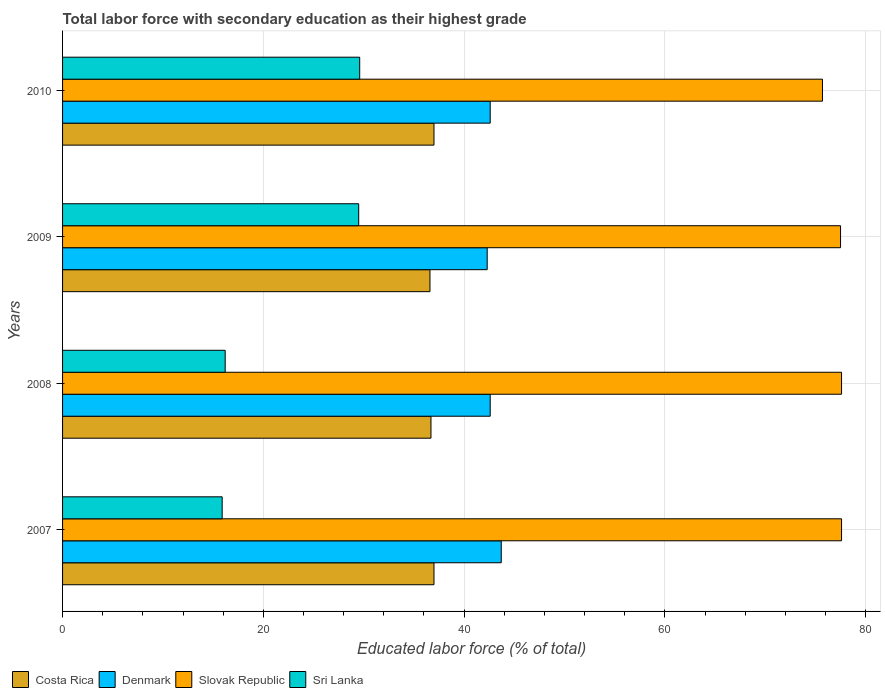How many groups of bars are there?
Your response must be concise. 4. Are the number of bars per tick equal to the number of legend labels?
Your answer should be very brief. Yes. How many bars are there on the 1st tick from the bottom?
Keep it short and to the point. 4. What is the label of the 1st group of bars from the top?
Keep it short and to the point. 2010. In how many cases, is the number of bars for a given year not equal to the number of legend labels?
Provide a succinct answer. 0. What is the percentage of total labor force with primary education in Denmark in 2007?
Ensure brevity in your answer.  43.7. Across all years, what is the maximum percentage of total labor force with primary education in Sri Lanka?
Make the answer very short. 29.6. Across all years, what is the minimum percentage of total labor force with primary education in Denmark?
Offer a very short reply. 42.3. In which year was the percentage of total labor force with primary education in Denmark minimum?
Make the answer very short. 2009. What is the total percentage of total labor force with primary education in Costa Rica in the graph?
Offer a terse response. 147.3. What is the difference between the percentage of total labor force with primary education in Slovak Republic in 2008 and that in 2010?
Your answer should be compact. 1.9. What is the difference between the percentage of total labor force with primary education in Sri Lanka in 2009 and the percentage of total labor force with primary education in Slovak Republic in 2008?
Ensure brevity in your answer.  -48.1. What is the average percentage of total labor force with primary education in Denmark per year?
Provide a short and direct response. 42.8. In the year 2008, what is the difference between the percentage of total labor force with primary education in Costa Rica and percentage of total labor force with primary education in Slovak Republic?
Offer a very short reply. -40.9. In how many years, is the percentage of total labor force with primary education in Denmark greater than 44 %?
Keep it short and to the point. 0. What is the ratio of the percentage of total labor force with primary education in Slovak Republic in 2008 to that in 2009?
Keep it short and to the point. 1. What is the difference between the highest and the second highest percentage of total labor force with primary education in Sri Lanka?
Keep it short and to the point. 0.1. What is the difference between the highest and the lowest percentage of total labor force with primary education in Costa Rica?
Make the answer very short. 0.4. What does the 2nd bar from the top in 2007 represents?
Provide a succinct answer. Slovak Republic. What does the 3rd bar from the bottom in 2009 represents?
Your response must be concise. Slovak Republic. How many bars are there?
Keep it short and to the point. 16. How many years are there in the graph?
Provide a succinct answer. 4. What is the difference between two consecutive major ticks on the X-axis?
Ensure brevity in your answer.  20. Does the graph contain grids?
Your answer should be very brief. Yes. How many legend labels are there?
Your answer should be compact. 4. What is the title of the graph?
Provide a short and direct response. Total labor force with secondary education as their highest grade. What is the label or title of the X-axis?
Your answer should be very brief. Educated labor force (% of total). What is the Educated labor force (% of total) of Denmark in 2007?
Offer a very short reply. 43.7. What is the Educated labor force (% of total) of Slovak Republic in 2007?
Your response must be concise. 77.6. What is the Educated labor force (% of total) of Sri Lanka in 2007?
Offer a terse response. 15.9. What is the Educated labor force (% of total) in Costa Rica in 2008?
Your response must be concise. 36.7. What is the Educated labor force (% of total) in Denmark in 2008?
Offer a very short reply. 42.6. What is the Educated labor force (% of total) of Slovak Republic in 2008?
Make the answer very short. 77.6. What is the Educated labor force (% of total) of Sri Lanka in 2008?
Your answer should be very brief. 16.2. What is the Educated labor force (% of total) in Costa Rica in 2009?
Your answer should be very brief. 36.6. What is the Educated labor force (% of total) in Denmark in 2009?
Give a very brief answer. 42.3. What is the Educated labor force (% of total) in Slovak Republic in 2009?
Make the answer very short. 77.5. What is the Educated labor force (% of total) in Sri Lanka in 2009?
Provide a short and direct response. 29.5. What is the Educated labor force (% of total) in Denmark in 2010?
Ensure brevity in your answer.  42.6. What is the Educated labor force (% of total) in Slovak Republic in 2010?
Provide a short and direct response. 75.7. What is the Educated labor force (% of total) of Sri Lanka in 2010?
Make the answer very short. 29.6. Across all years, what is the maximum Educated labor force (% of total) of Costa Rica?
Keep it short and to the point. 37. Across all years, what is the maximum Educated labor force (% of total) of Denmark?
Your response must be concise. 43.7. Across all years, what is the maximum Educated labor force (% of total) in Slovak Republic?
Your answer should be very brief. 77.6. Across all years, what is the maximum Educated labor force (% of total) in Sri Lanka?
Offer a terse response. 29.6. Across all years, what is the minimum Educated labor force (% of total) of Costa Rica?
Ensure brevity in your answer.  36.6. Across all years, what is the minimum Educated labor force (% of total) of Denmark?
Ensure brevity in your answer.  42.3. Across all years, what is the minimum Educated labor force (% of total) in Slovak Republic?
Provide a short and direct response. 75.7. Across all years, what is the minimum Educated labor force (% of total) of Sri Lanka?
Ensure brevity in your answer.  15.9. What is the total Educated labor force (% of total) in Costa Rica in the graph?
Your answer should be very brief. 147.3. What is the total Educated labor force (% of total) in Denmark in the graph?
Your answer should be compact. 171.2. What is the total Educated labor force (% of total) of Slovak Republic in the graph?
Your response must be concise. 308.4. What is the total Educated labor force (% of total) in Sri Lanka in the graph?
Provide a short and direct response. 91.2. What is the difference between the Educated labor force (% of total) of Costa Rica in 2007 and that in 2008?
Your response must be concise. 0.3. What is the difference between the Educated labor force (% of total) in Costa Rica in 2007 and that in 2009?
Give a very brief answer. 0.4. What is the difference between the Educated labor force (% of total) of Denmark in 2007 and that in 2009?
Provide a succinct answer. 1.4. What is the difference between the Educated labor force (% of total) in Slovak Republic in 2007 and that in 2009?
Provide a succinct answer. 0.1. What is the difference between the Educated labor force (% of total) of Sri Lanka in 2007 and that in 2009?
Make the answer very short. -13.6. What is the difference between the Educated labor force (% of total) of Costa Rica in 2007 and that in 2010?
Ensure brevity in your answer.  0. What is the difference between the Educated labor force (% of total) of Denmark in 2007 and that in 2010?
Make the answer very short. 1.1. What is the difference between the Educated labor force (% of total) of Slovak Republic in 2007 and that in 2010?
Keep it short and to the point. 1.9. What is the difference between the Educated labor force (% of total) of Sri Lanka in 2007 and that in 2010?
Your response must be concise. -13.7. What is the difference between the Educated labor force (% of total) of Costa Rica in 2008 and that in 2009?
Your answer should be very brief. 0.1. What is the difference between the Educated labor force (% of total) of Slovak Republic in 2008 and that in 2009?
Your answer should be compact. 0.1. What is the difference between the Educated labor force (% of total) in Sri Lanka in 2008 and that in 2009?
Keep it short and to the point. -13.3. What is the difference between the Educated labor force (% of total) of Costa Rica in 2008 and that in 2010?
Offer a terse response. -0.3. What is the difference between the Educated labor force (% of total) of Denmark in 2008 and that in 2010?
Give a very brief answer. 0. What is the difference between the Educated labor force (% of total) of Slovak Republic in 2008 and that in 2010?
Provide a short and direct response. 1.9. What is the difference between the Educated labor force (% of total) in Slovak Republic in 2009 and that in 2010?
Offer a terse response. 1.8. What is the difference between the Educated labor force (% of total) in Sri Lanka in 2009 and that in 2010?
Provide a succinct answer. -0.1. What is the difference between the Educated labor force (% of total) of Costa Rica in 2007 and the Educated labor force (% of total) of Denmark in 2008?
Give a very brief answer. -5.6. What is the difference between the Educated labor force (% of total) of Costa Rica in 2007 and the Educated labor force (% of total) of Slovak Republic in 2008?
Provide a succinct answer. -40.6. What is the difference between the Educated labor force (% of total) of Costa Rica in 2007 and the Educated labor force (% of total) of Sri Lanka in 2008?
Make the answer very short. 20.8. What is the difference between the Educated labor force (% of total) in Denmark in 2007 and the Educated labor force (% of total) in Slovak Republic in 2008?
Ensure brevity in your answer.  -33.9. What is the difference between the Educated labor force (% of total) in Slovak Republic in 2007 and the Educated labor force (% of total) in Sri Lanka in 2008?
Keep it short and to the point. 61.4. What is the difference between the Educated labor force (% of total) in Costa Rica in 2007 and the Educated labor force (% of total) in Slovak Republic in 2009?
Your answer should be very brief. -40.5. What is the difference between the Educated labor force (% of total) in Costa Rica in 2007 and the Educated labor force (% of total) in Sri Lanka in 2009?
Offer a terse response. 7.5. What is the difference between the Educated labor force (% of total) of Denmark in 2007 and the Educated labor force (% of total) of Slovak Republic in 2009?
Give a very brief answer. -33.8. What is the difference between the Educated labor force (% of total) of Slovak Republic in 2007 and the Educated labor force (% of total) of Sri Lanka in 2009?
Your answer should be compact. 48.1. What is the difference between the Educated labor force (% of total) of Costa Rica in 2007 and the Educated labor force (% of total) of Slovak Republic in 2010?
Ensure brevity in your answer.  -38.7. What is the difference between the Educated labor force (% of total) of Costa Rica in 2007 and the Educated labor force (% of total) of Sri Lanka in 2010?
Your response must be concise. 7.4. What is the difference between the Educated labor force (% of total) of Denmark in 2007 and the Educated labor force (% of total) of Slovak Republic in 2010?
Your answer should be very brief. -32. What is the difference between the Educated labor force (% of total) in Costa Rica in 2008 and the Educated labor force (% of total) in Denmark in 2009?
Offer a terse response. -5.6. What is the difference between the Educated labor force (% of total) in Costa Rica in 2008 and the Educated labor force (% of total) in Slovak Republic in 2009?
Keep it short and to the point. -40.8. What is the difference between the Educated labor force (% of total) of Costa Rica in 2008 and the Educated labor force (% of total) of Sri Lanka in 2009?
Your response must be concise. 7.2. What is the difference between the Educated labor force (% of total) of Denmark in 2008 and the Educated labor force (% of total) of Slovak Republic in 2009?
Offer a very short reply. -34.9. What is the difference between the Educated labor force (% of total) of Slovak Republic in 2008 and the Educated labor force (% of total) of Sri Lanka in 2009?
Offer a very short reply. 48.1. What is the difference between the Educated labor force (% of total) of Costa Rica in 2008 and the Educated labor force (% of total) of Slovak Republic in 2010?
Give a very brief answer. -39. What is the difference between the Educated labor force (% of total) of Denmark in 2008 and the Educated labor force (% of total) of Slovak Republic in 2010?
Make the answer very short. -33.1. What is the difference between the Educated labor force (% of total) in Denmark in 2008 and the Educated labor force (% of total) in Sri Lanka in 2010?
Keep it short and to the point. 13. What is the difference between the Educated labor force (% of total) of Slovak Republic in 2008 and the Educated labor force (% of total) of Sri Lanka in 2010?
Offer a very short reply. 48. What is the difference between the Educated labor force (% of total) of Costa Rica in 2009 and the Educated labor force (% of total) of Denmark in 2010?
Provide a short and direct response. -6. What is the difference between the Educated labor force (% of total) of Costa Rica in 2009 and the Educated labor force (% of total) of Slovak Republic in 2010?
Offer a terse response. -39.1. What is the difference between the Educated labor force (% of total) of Denmark in 2009 and the Educated labor force (% of total) of Slovak Republic in 2010?
Offer a terse response. -33.4. What is the difference between the Educated labor force (% of total) in Slovak Republic in 2009 and the Educated labor force (% of total) in Sri Lanka in 2010?
Provide a short and direct response. 47.9. What is the average Educated labor force (% of total) of Costa Rica per year?
Ensure brevity in your answer.  36.83. What is the average Educated labor force (% of total) in Denmark per year?
Your answer should be very brief. 42.8. What is the average Educated labor force (% of total) of Slovak Republic per year?
Your answer should be compact. 77.1. What is the average Educated labor force (% of total) in Sri Lanka per year?
Make the answer very short. 22.8. In the year 2007, what is the difference between the Educated labor force (% of total) in Costa Rica and Educated labor force (% of total) in Denmark?
Offer a very short reply. -6.7. In the year 2007, what is the difference between the Educated labor force (% of total) of Costa Rica and Educated labor force (% of total) of Slovak Republic?
Give a very brief answer. -40.6. In the year 2007, what is the difference between the Educated labor force (% of total) in Costa Rica and Educated labor force (% of total) in Sri Lanka?
Your answer should be very brief. 21.1. In the year 2007, what is the difference between the Educated labor force (% of total) of Denmark and Educated labor force (% of total) of Slovak Republic?
Ensure brevity in your answer.  -33.9. In the year 2007, what is the difference between the Educated labor force (% of total) in Denmark and Educated labor force (% of total) in Sri Lanka?
Your response must be concise. 27.8. In the year 2007, what is the difference between the Educated labor force (% of total) of Slovak Republic and Educated labor force (% of total) of Sri Lanka?
Keep it short and to the point. 61.7. In the year 2008, what is the difference between the Educated labor force (% of total) of Costa Rica and Educated labor force (% of total) of Denmark?
Your response must be concise. -5.9. In the year 2008, what is the difference between the Educated labor force (% of total) in Costa Rica and Educated labor force (% of total) in Slovak Republic?
Your response must be concise. -40.9. In the year 2008, what is the difference between the Educated labor force (% of total) in Denmark and Educated labor force (% of total) in Slovak Republic?
Make the answer very short. -35. In the year 2008, what is the difference between the Educated labor force (% of total) of Denmark and Educated labor force (% of total) of Sri Lanka?
Ensure brevity in your answer.  26.4. In the year 2008, what is the difference between the Educated labor force (% of total) of Slovak Republic and Educated labor force (% of total) of Sri Lanka?
Provide a short and direct response. 61.4. In the year 2009, what is the difference between the Educated labor force (% of total) in Costa Rica and Educated labor force (% of total) in Slovak Republic?
Your answer should be compact. -40.9. In the year 2009, what is the difference between the Educated labor force (% of total) in Costa Rica and Educated labor force (% of total) in Sri Lanka?
Provide a succinct answer. 7.1. In the year 2009, what is the difference between the Educated labor force (% of total) of Denmark and Educated labor force (% of total) of Slovak Republic?
Give a very brief answer. -35.2. In the year 2009, what is the difference between the Educated labor force (% of total) of Denmark and Educated labor force (% of total) of Sri Lanka?
Keep it short and to the point. 12.8. In the year 2009, what is the difference between the Educated labor force (% of total) of Slovak Republic and Educated labor force (% of total) of Sri Lanka?
Make the answer very short. 48. In the year 2010, what is the difference between the Educated labor force (% of total) in Costa Rica and Educated labor force (% of total) in Slovak Republic?
Offer a very short reply. -38.7. In the year 2010, what is the difference between the Educated labor force (% of total) in Costa Rica and Educated labor force (% of total) in Sri Lanka?
Provide a short and direct response. 7.4. In the year 2010, what is the difference between the Educated labor force (% of total) of Denmark and Educated labor force (% of total) of Slovak Republic?
Ensure brevity in your answer.  -33.1. In the year 2010, what is the difference between the Educated labor force (% of total) in Slovak Republic and Educated labor force (% of total) in Sri Lanka?
Keep it short and to the point. 46.1. What is the ratio of the Educated labor force (% of total) of Costa Rica in 2007 to that in 2008?
Ensure brevity in your answer.  1.01. What is the ratio of the Educated labor force (% of total) of Denmark in 2007 to that in 2008?
Provide a short and direct response. 1.03. What is the ratio of the Educated labor force (% of total) in Slovak Republic in 2007 to that in 2008?
Provide a short and direct response. 1. What is the ratio of the Educated labor force (% of total) in Sri Lanka in 2007 to that in 2008?
Your answer should be compact. 0.98. What is the ratio of the Educated labor force (% of total) of Costa Rica in 2007 to that in 2009?
Give a very brief answer. 1.01. What is the ratio of the Educated labor force (% of total) in Denmark in 2007 to that in 2009?
Provide a short and direct response. 1.03. What is the ratio of the Educated labor force (% of total) of Sri Lanka in 2007 to that in 2009?
Offer a very short reply. 0.54. What is the ratio of the Educated labor force (% of total) of Costa Rica in 2007 to that in 2010?
Make the answer very short. 1. What is the ratio of the Educated labor force (% of total) in Denmark in 2007 to that in 2010?
Give a very brief answer. 1.03. What is the ratio of the Educated labor force (% of total) of Slovak Republic in 2007 to that in 2010?
Offer a very short reply. 1.03. What is the ratio of the Educated labor force (% of total) in Sri Lanka in 2007 to that in 2010?
Your answer should be very brief. 0.54. What is the ratio of the Educated labor force (% of total) of Denmark in 2008 to that in 2009?
Provide a short and direct response. 1.01. What is the ratio of the Educated labor force (% of total) of Slovak Republic in 2008 to that in 2009?
Offer a terse response. 1. What is the ratio of the Educated labor force (% of total) in Sri Lanka in 2008 to that in 2009?
Your answer should be very brief. 0.55. What is the ratio of the Educated labor force (% of total) in Denmark in 2008 to that in 2010?
Ensure brevity in your answer.  1. What is the ratio of the Educated labor force (% of total) of Slovak Republic in 2008 to that in 2010?
Keep it short and to the point. 1.03. What is the ratio of the Educated labor force (% of total) in Sri Lanka in 2008 to that in 2010?
Offer a terse response. 0.55. What is the ratio of the Educated labor force (% of total) in Costa Rica in 2009 to that in 2010?
Make the answer very short. 0.99. What is the ratio of the Educated labor force (% of total) of Slovak Republic in 2009 to that in 2010?
Offer a very short reply. 1.02. What is the ratio of the Educated labor force (% of total) of Sri Lanka in 2009 to that in 2010?
Provide a short and direct response. 1. What is the difference between the highest and the second highest Educated labor force (% of total) of Costa Rica?
Your response must be concise. 0. What is the difference between the highest and the second highest Educated labor force (% of total) in Denmark?
Ensure brevity in your answer.  1.1. What is the difference between the highest and the second highest Educated labor force (% of total) of Sri Lanka?
Your answer should be compact. 0.1. What is the difference between the highest and the lowest Educated labor force (% of total) in Slovak Republic?
Your answer should be compact. 1.9. What is the difference between the highest and the lowest Educated labor force (% of total) of Sri Lanka?
Your answer should be very brief. 13.7. 